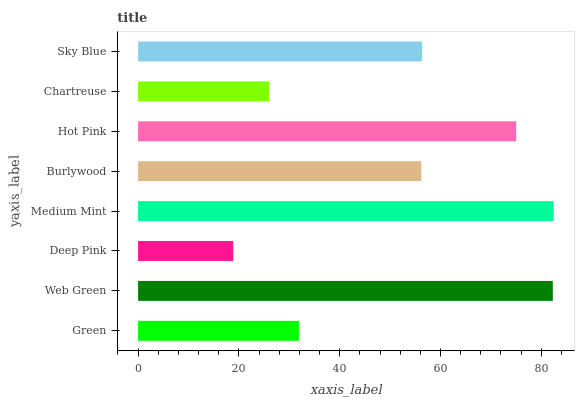Is Deep Pink the minimum?
Answer yes or no. Yes. Is Medium Mint the maximum?
Answer yes or no. Yes. Is Web Green the minimum?
Answer yes or no. No. Is Web Green the maximum?
Answer yes or no. No. Is Web Green greater than Green?
Answer yes or no. Yes. Is Green less than Web Green?
Answer yes or no. Yes. Is Green greater than Web Green?
Answer yes or no. No. Is Web Green less than Green?
Answer yes or no. No. Is Sky Blue the high median?
Answer yes or no. Yes. Is Burlywood the low median?
Answer yes or no. Yes. Is Web Green the high median?
Answer yes or no. No. Is Deep Pink the low median?
Answer yes or no. No. 